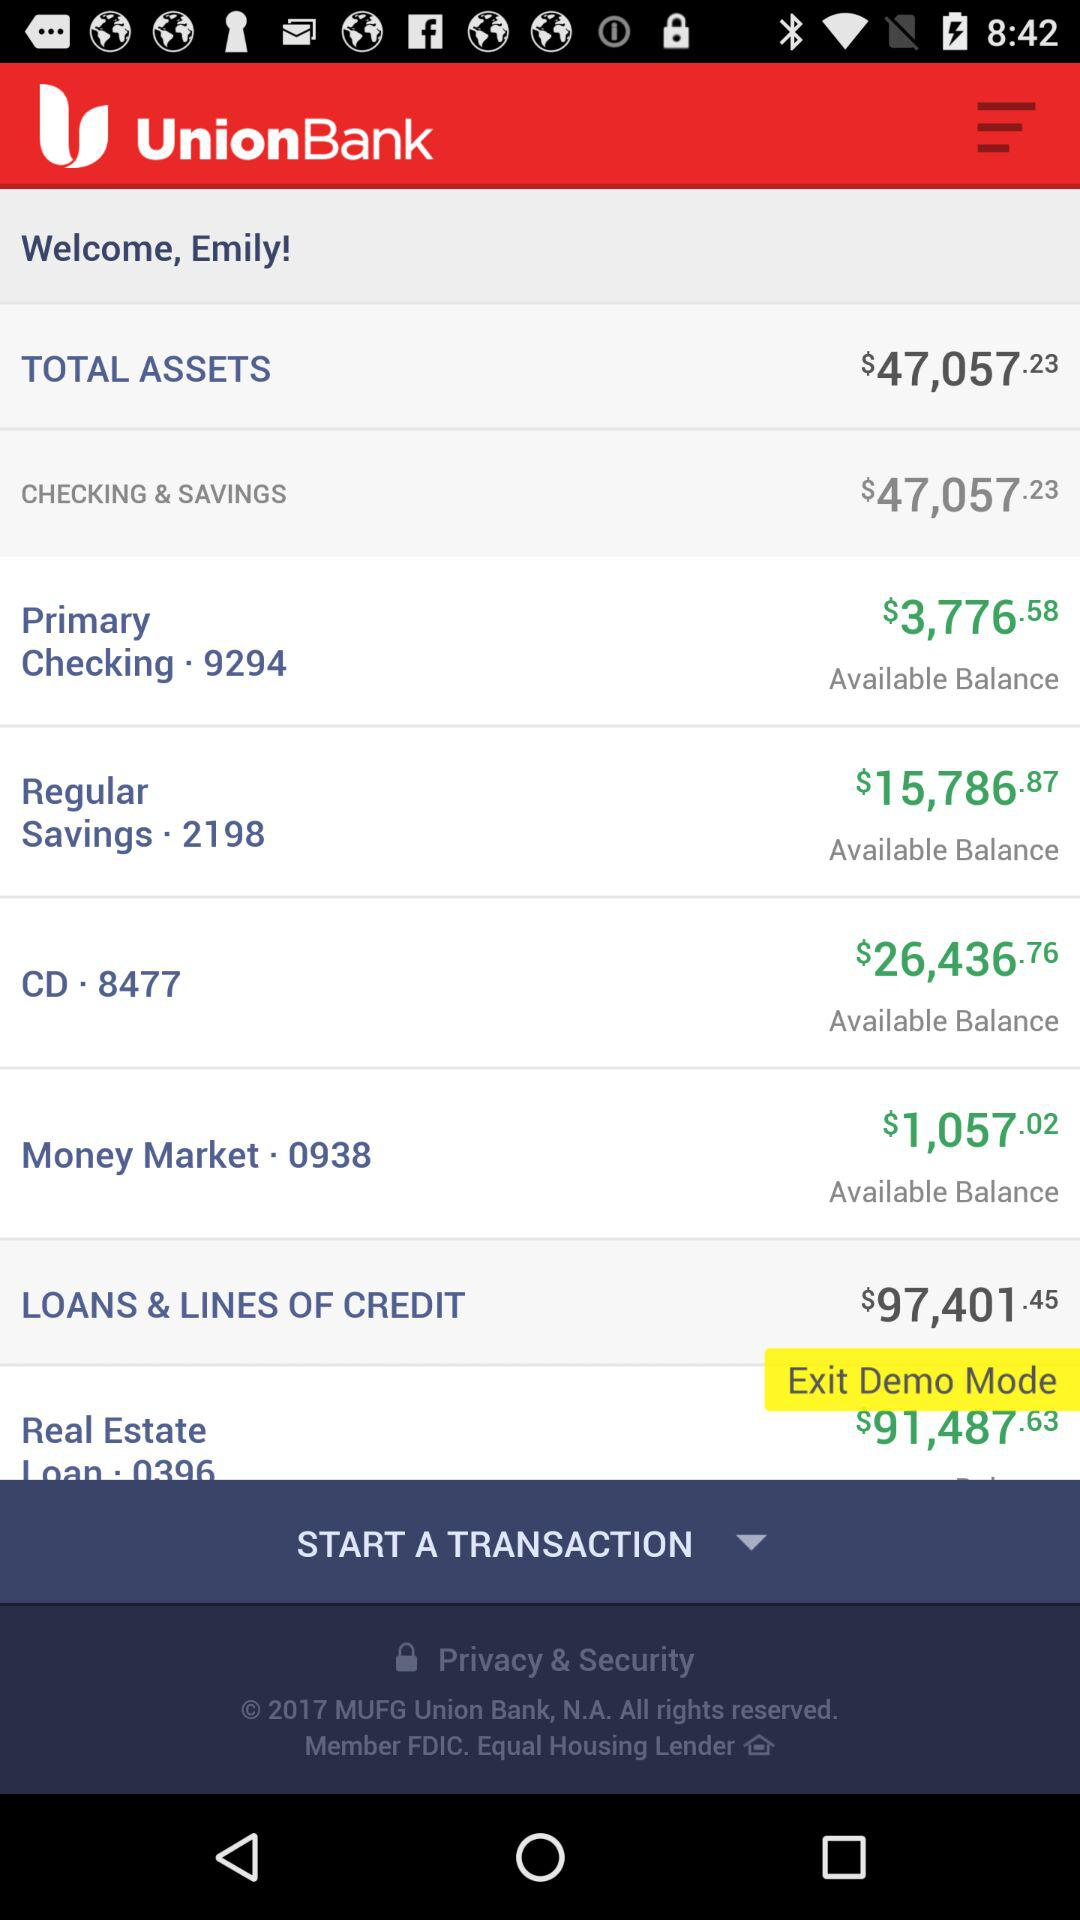How much of the balance is in regular savings? The regular savings balance is $15,786.87. 